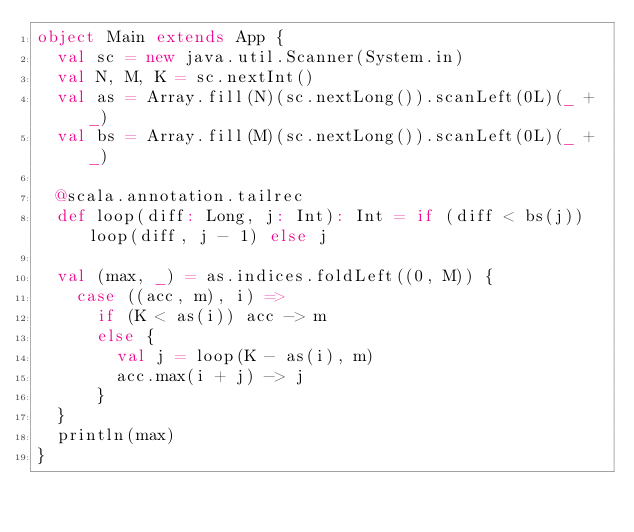<code> <loc_0><loc_0><loc_500><loc_500><_Scala_>object Main extends App {
  val sc = new java.util.Scanner(System.in)
  val N, M, K = sc.nextInt()
  val as = Array.fill(N)(sc.nextLong()).scanLeft(0L)(_ + _)
  val bs = Array.fill(M)(sc.nextLong()).scanLeft(0L)(_ + _)

  @scala.annotation.tailrec
  def loop(diff: Long, j: Int): Int = if (diff < bs(j)) loop(diff, j - 1) else j

  val (max, _) = as.indices.foldLeft((0, M)) {
    case ((acc, m), i) =>
      if (K < as(i)) acc -> m
      else {
        val j = loop(K - as(i), m)
        acc.max(i + j) -> j
      }
  }
  println(max)
}
</code> 